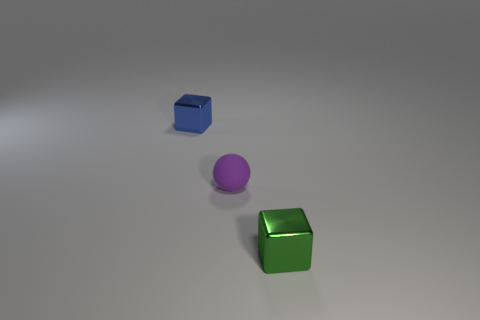How many objects are there in the image, and can you describe them? There are three objects in the image: a blue cube, a purple sphere, and a green cube. All objects have a shiny surface and are scattered on an even surface with a neutral color. 